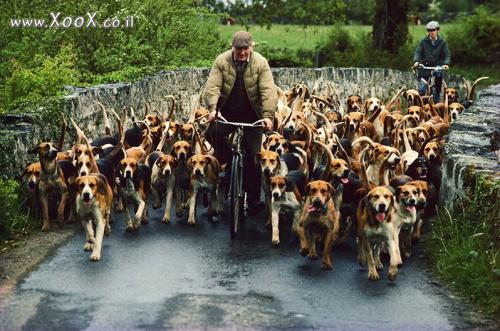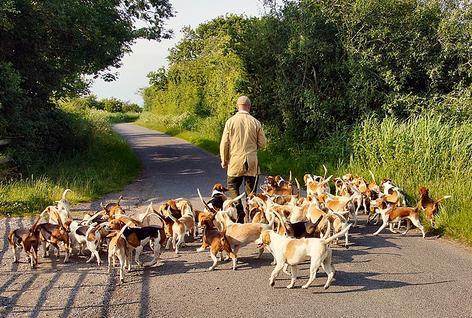The first image is the image on the left, the second image is the image on the right. Analyze the images presented: Is the assertion "There are no people in one of the images." valid? Answer yes or no. No. The first image is the image on the left, the second image is the image on the right. Given the left and right images, does the statement "In one image, at least two people wearing hunting jackets with white breeches and black boots are on foot with a pack of hunting dogs." hold true? Answer yes or no. No. 